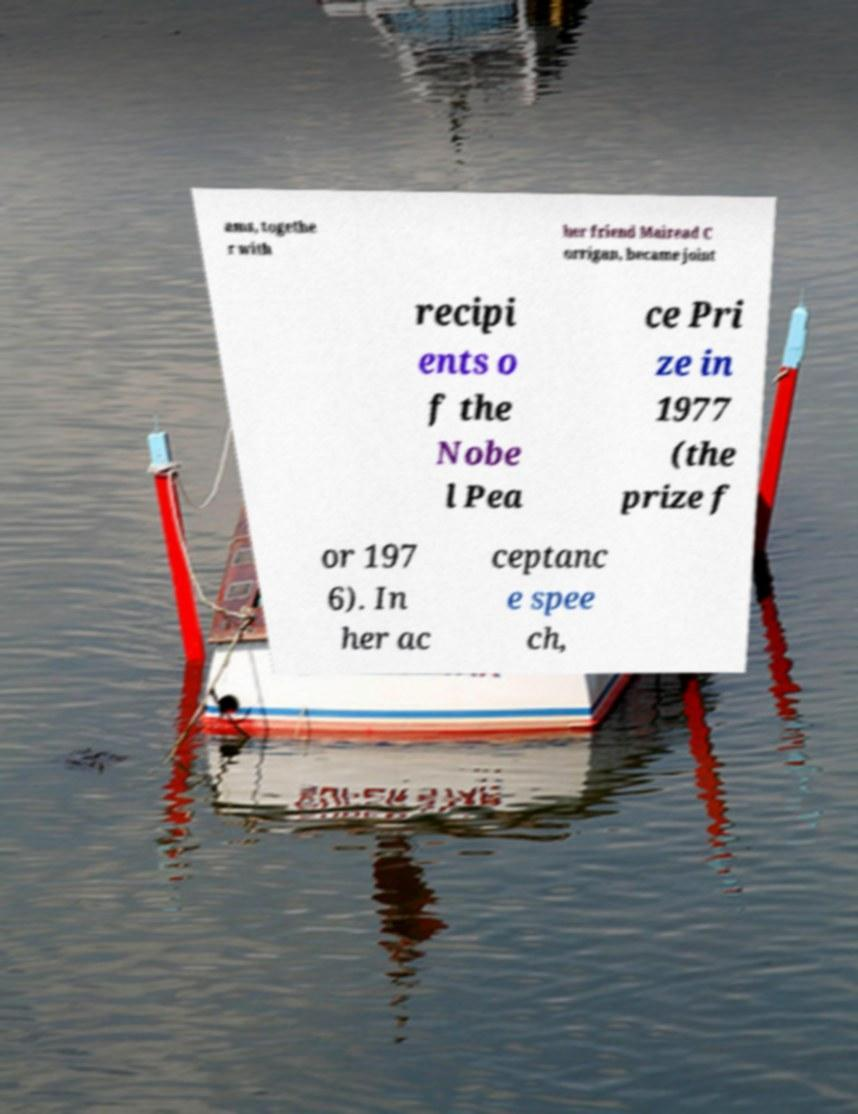There's text embedded in this image that I need extracted. Can you transcribe it verbatim? ams, togethe r with her friend Mairead C orrigan, became joint recipi ents o f the Nobe l Pea ce Pri ze in 1977 (the prize f or 197 6). In her ac ceptanc e spee ch, 